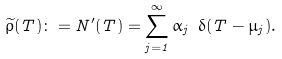Convert formula to latex. <formula><loc_0><loc_0><loc_500><loc_500>\widetilde { \rho } ( T ) \colon = N ^ { \prime } ( T ) = \sum _ { j = 1 } ^ { \infty } \alpha _ { j } \ \delta ( T - \mu _ { j } ) .</formula> 